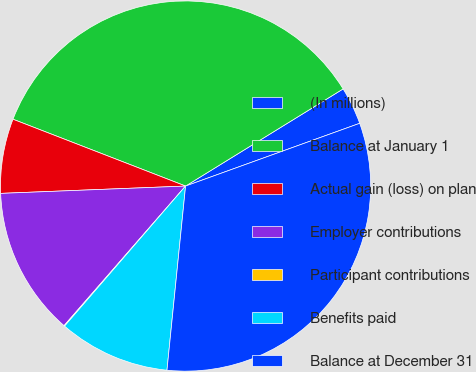Convert chart. <chart><loc_0><loc_0><loc_500><loc_500><pie_chart><fcel>(In millions)<fcel>Balance at January 1<fcel>Actual gain (loss) on plan<fcel>Employer contributions<fcel>Participant contributions<fcel>Benefits paid<fcel>Balance at December 31<nl><fcel>3.29%<fcel>35.33%<fcel>6.51%<fcel>12.97%<fcel>0.06%<fcel>9.74%<fcel>32.11%<nl></chart> 